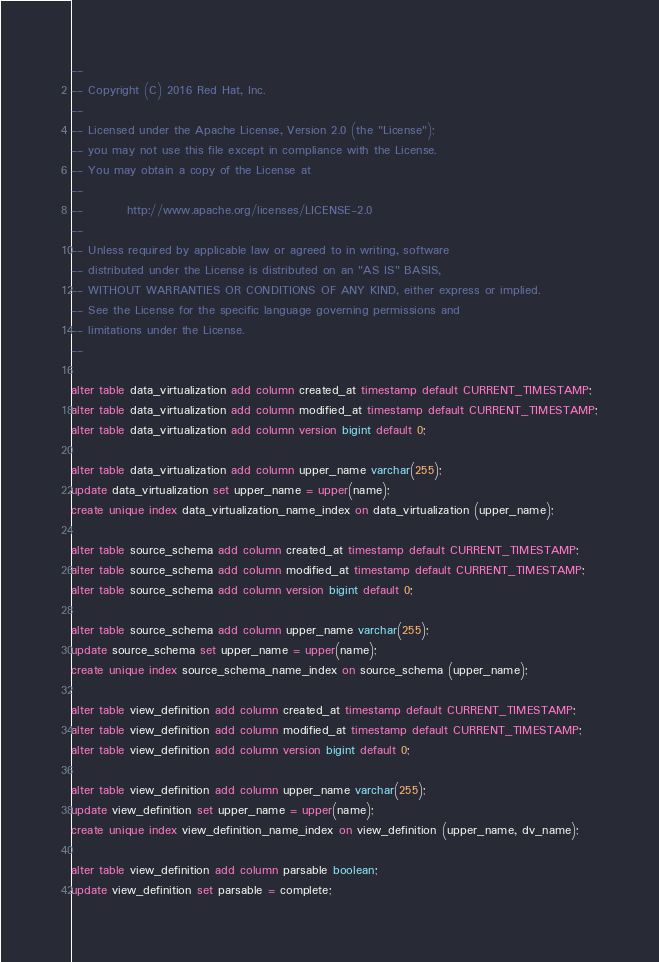Convert code to text. <code><loc_0><loc_0><loc_500><loc_500><_SQL_>--
-- Copyright (C) 2016 Red Hat, Inc.
--
-- Licensed under the Apache License, Version 2.0 (the "License");
-- you may not use this file except in compliance with the License.
-- You may obtain a copy of the License at
--
--         http://www.apache.org/licenses/LICENSE-2.0
--
-- Unless required by applicable law or agreed to in writing, software
-- distributed under the License is distributed on an "AS IS" BASIS,
-- WITHOUT WARRANTIES OR CONDITIONS OF ANY KIND, either express or implied.
-- See the License for the specific language governing permissions and
-- limitations under the License.
--

alter table data_virtualization add column created_at timestamp default CURRENT_TIMESTAMP;
alter table data_virtualization add column modified_at timestamp default CURRENT_TIMESTAMP;
alter table data_virtualization add column version bigint default 0;

alter table data_virtualization add column upper_name varchar(255);
update data_virtualization set upper_name = upper(name);
create unique index data_virtualization_name_index on data_virtualization (upper_name);

alter table source_schema add column created_at timestamp default CURRENT_TIMESTAMP;
alter table source_schema add column modified_at timestamp default CURRENT_TIMESTAMP;
alter table source_schema add column version bigint default 0;

alter table source_schema add column upper_name varchar(255);
update source_schema set upper_name = upper(name);
create unique index source_schema_name_index on source_schema (upper_name);

alter table view_definition add column created_at timestamp default CURRENT_TIMESTAMP; 
alter table view_definition add column modified_at timestamp default CURRENT_TIMESTAMP;
alter table view_definition add column version bigint default 0;

alter table view_definition add column upper_name varchar(255);
update view_definition set upper_name = upper(name);
create unique index view_definition_name_index on view_definition (upper_name, dv_name);

alter table view_definition add column parsable boolean;
update view_definition set parsable = complete;
</code> 